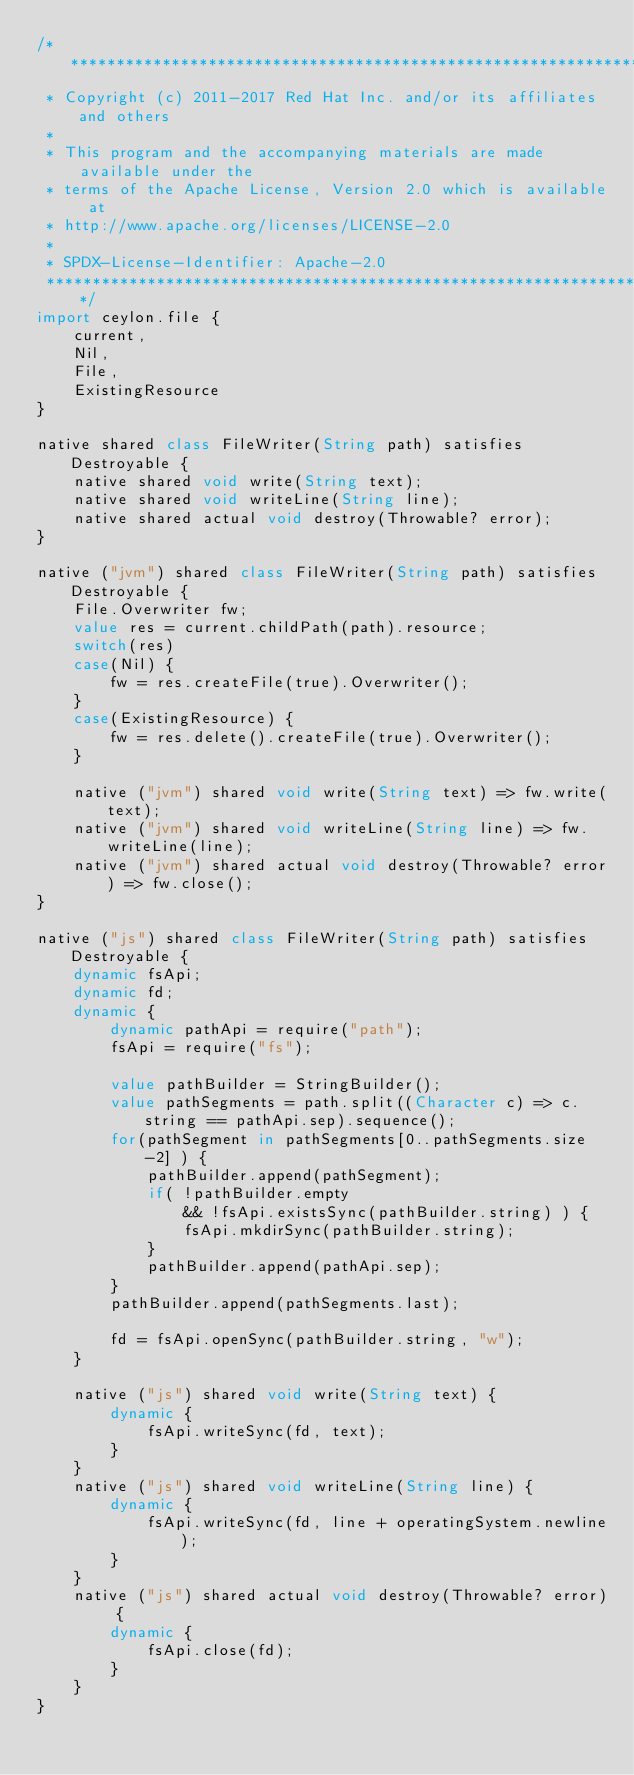Convert code to text. <code><loc_0><loc_0><loc_500><loc_500><_Ceylon_>/********************************************************************************
 * Copyright (c) 2011-2017 Red Hat Inc. and/or its affiliates and others
 *
 * This program and the accompanying materials are made available under the 
 * terms of the Apache License, Version 2.0 which is available at
 * http://www.apache.org/licenses/LICENSE-2.0
 *
 * SPDX-License-Identifier: Apache-2.0 
 ********************************************************************************/
import ceylon.file {
    current,
    Nil,
    File,
    ExistingResource
}

native shared class FileWriter(String path) satisfies Destroyable {
    native shared void write(String text);
    native shared void writeLine(String line);
    native shared actual void destroy(Throwable? error);
}

native ("jvm") shared class FileWriter(String path) satisfies Destroyable {
    File.Overwriter fw;
    value res = current.childPath(path).resource;
    switch(res)
    case(Nil) {
        fw = res.createFile(true).Overwriter();
    }
    case(ExistingResource) {
        fw = res.delete().createFile(true).Overwriter();
    }
    
    native ("jvm") shared void write(String text) => fw.write(text);
    native ("jvm") shared void writeLine(String line) => fw.writeLine(line);
    native ("jvm") shared actual void destroy(Throwable? error) => fw.close();
}

native ("js") shared class FileWriter(String path) satisfies Destroyable {
    dynamic fsApi;
    dynamic fd;
    dynamic {
        dynamic pathApi = require("path");
        fsApi = require("fs");
        
        value pathBuilder = StringBuilder();
        value pathSegments = path.split((Character c) => c.string == pathApi.sep).sequence();
        for(pathSegment in pathSegments[0..pathSegments.size-2] ) {
            pathBuilder.append(pathSegment);
            if( !pathBuilder.empty
                && !fsApi.existsSync(pathBuilder.string) ) {
                fsApi.mkdirSync(pathBuilder.string);
            }
            pathBuilder.append(pathApi.sep);
        }
        pathBuilder.append(pathSegments.last);
        
        fd = fsApi.openSync(pathBuilder.string, "w");
    }
    
    native ("js") shared void write(String text) {
        dynamic {
            fsApi.writeSync(fd, text);
        }
    }
    native ("js") shared void writeLine(String line) {
        dynamic {
            fsApi.writeSync(fd, line + operatingSystem.newline);
        }
    }
    native ("js") shared actual void destroy(Throwable? error) {
        dynamic {
            fsApi.close(fd);
        }
    }
}    
</code> 